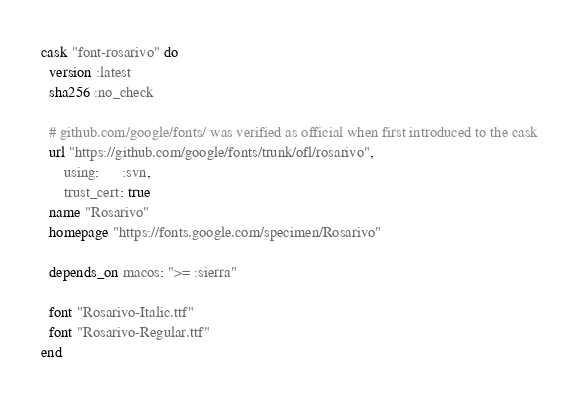<code> <loc_0><loc_0><loc_500><loc_500><_Ruby_>cask "font-rosarivo" do
  version :latest
  sha256 :no_check

  # github.com/google/fonts/ was verified as official when first introduced to the cask
  url "https://github.com/google/fonts/trunk/ofl/rosarivo",
      using:      :svn,
      trust_cert: true
  name "Rosarivo"
  homepage "https://fonts.google.com/specimen/Rosarivo"

  depends_on macos: ">= :sierra"

  font "Rosarivo-Italic.ttf"
  font "Rosarivo-Regular.ttf"
end
</code> 